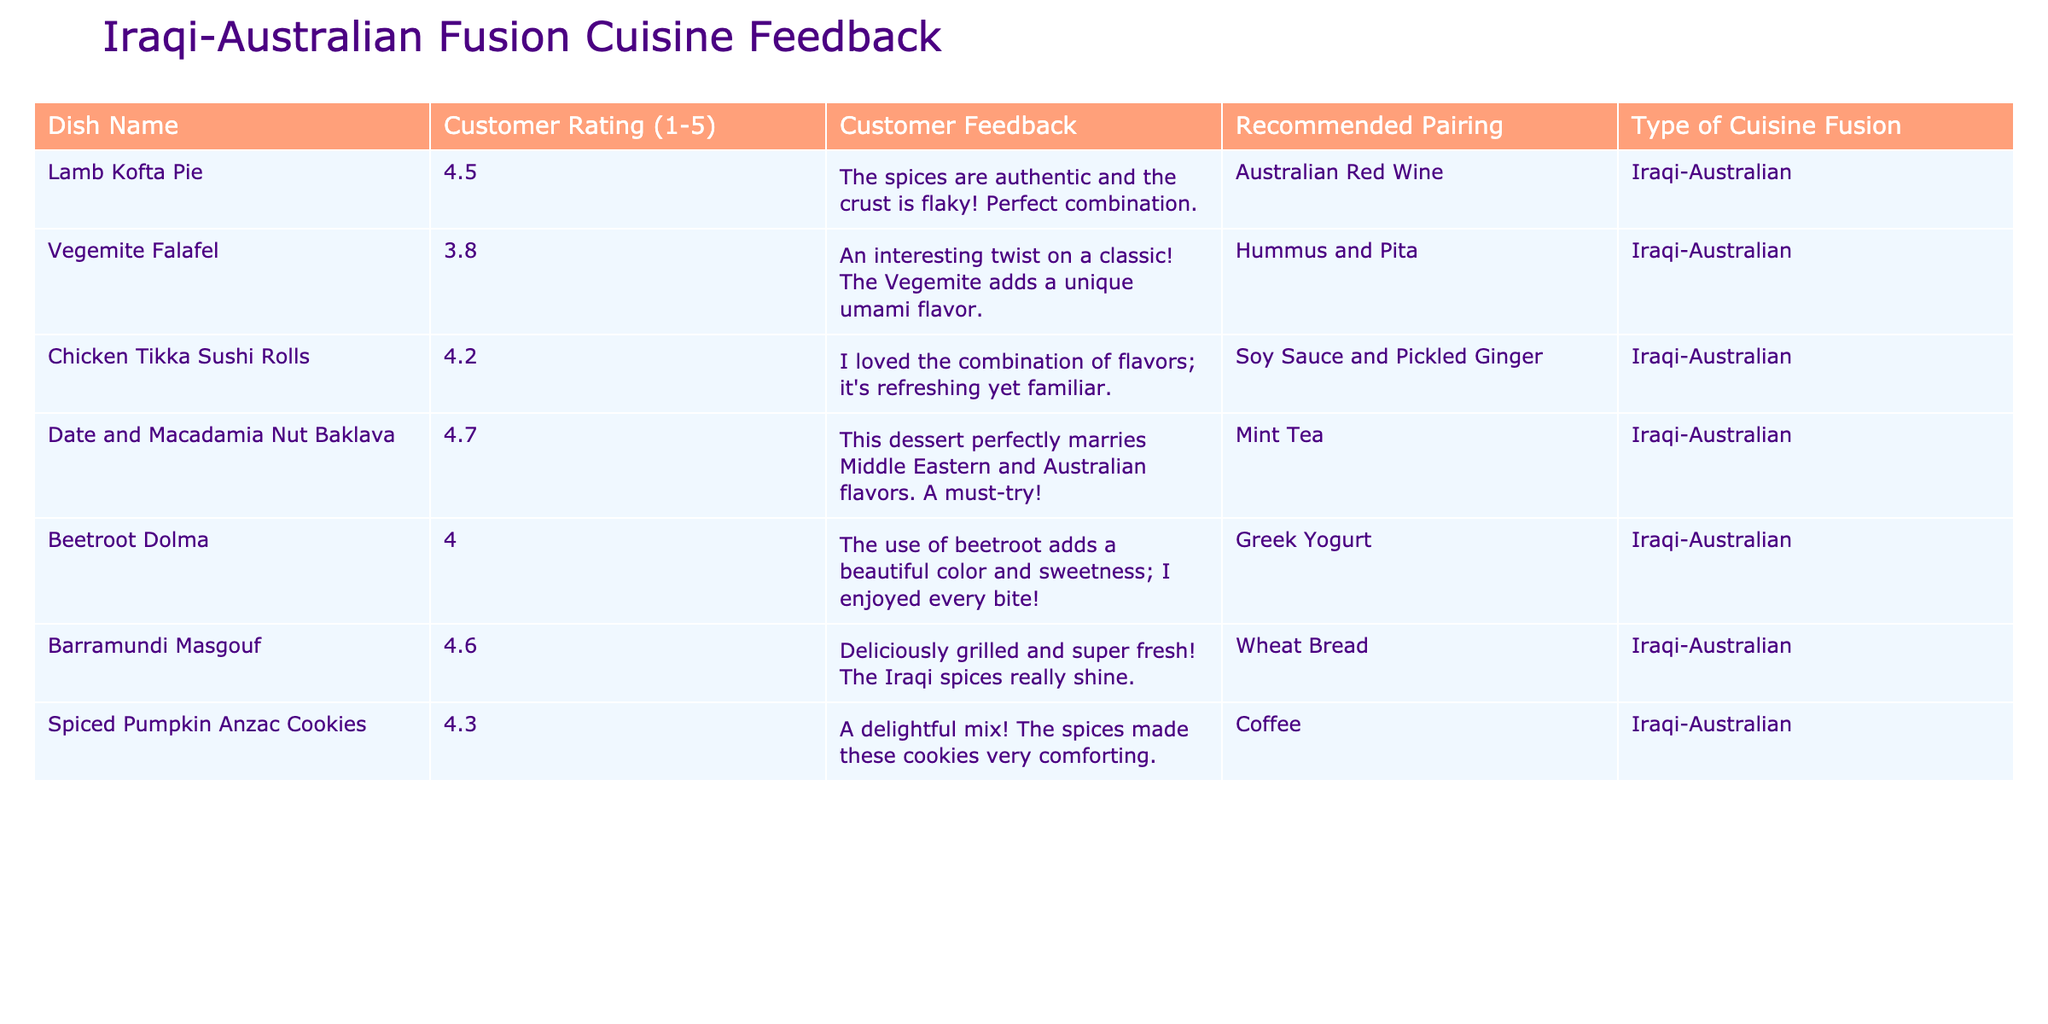What is the customer rating for the Lamb Kofta Pie? The table displays the rating for Lamb Kofta Pie as 4.5.
Answer: 4.5 Which dish has the highest customer rating? By examining the ratings of all dishes, the Date and Macadamia Nut Baklava has the highest rating of 4.7.
Answer: Date and Macadamia Nut Baklava What is the recommended pairing for the Chicken Tikka Sushi Rolls? The table indicates that the recommended pairing for Chicken Tikka Sushi Rolls is Soy Sauce and Pickled Ginger.
Answer: Soy Sauce and Pickled Ginger What is the average customer rating of all dishes listed? To find the average, add the ratings (4.5 + 3.8 + 4.2 + 4.7 + 4.0 + 4.6 + 4.3) = 30.1 and divide by the number of dishes (7). The average rating is approximately 4.3.
Answer: 4.3 Are there any dishes with a rating of 5.0? Looking at the ratings provided, there are no dishes with a rating of 5.0.
Answer: No Which two dishes have a rating higher than 4.5 and what are their feedback? The Date and Macadamia Nut Baklava (4.7) and Barramundi Masgouf (4.6) have ratings higher than 4.5. The feedback for Baklava is that it perfectly marries Middle Eastern and Australian flavors, while Masgouf's feedback states it is deliciously grilled with shining Iraqi spices.
Answer: Date and Macadamia Nut Baklava and Barramundi Masgouf Which dish would you recommend pairing with a sweet beverage? The Date and Macadamia Nut Baklava's recommended pairing is Mint Tea, which is typically considered a sweet beverage.
Answer: Date and Macadamia Nut Baklava Is the Vegemite Falafel rated lower than 4.0? The Vegemite Falafel has a rating of 3.8, which is indeed lower than 4.0.
Answer: Yes How many dishes have a recommended pairing of a type of bread? Only one dish, Barramundi Masgouf, has a recommended pairing of Wheat Bread.
Answer: 1 